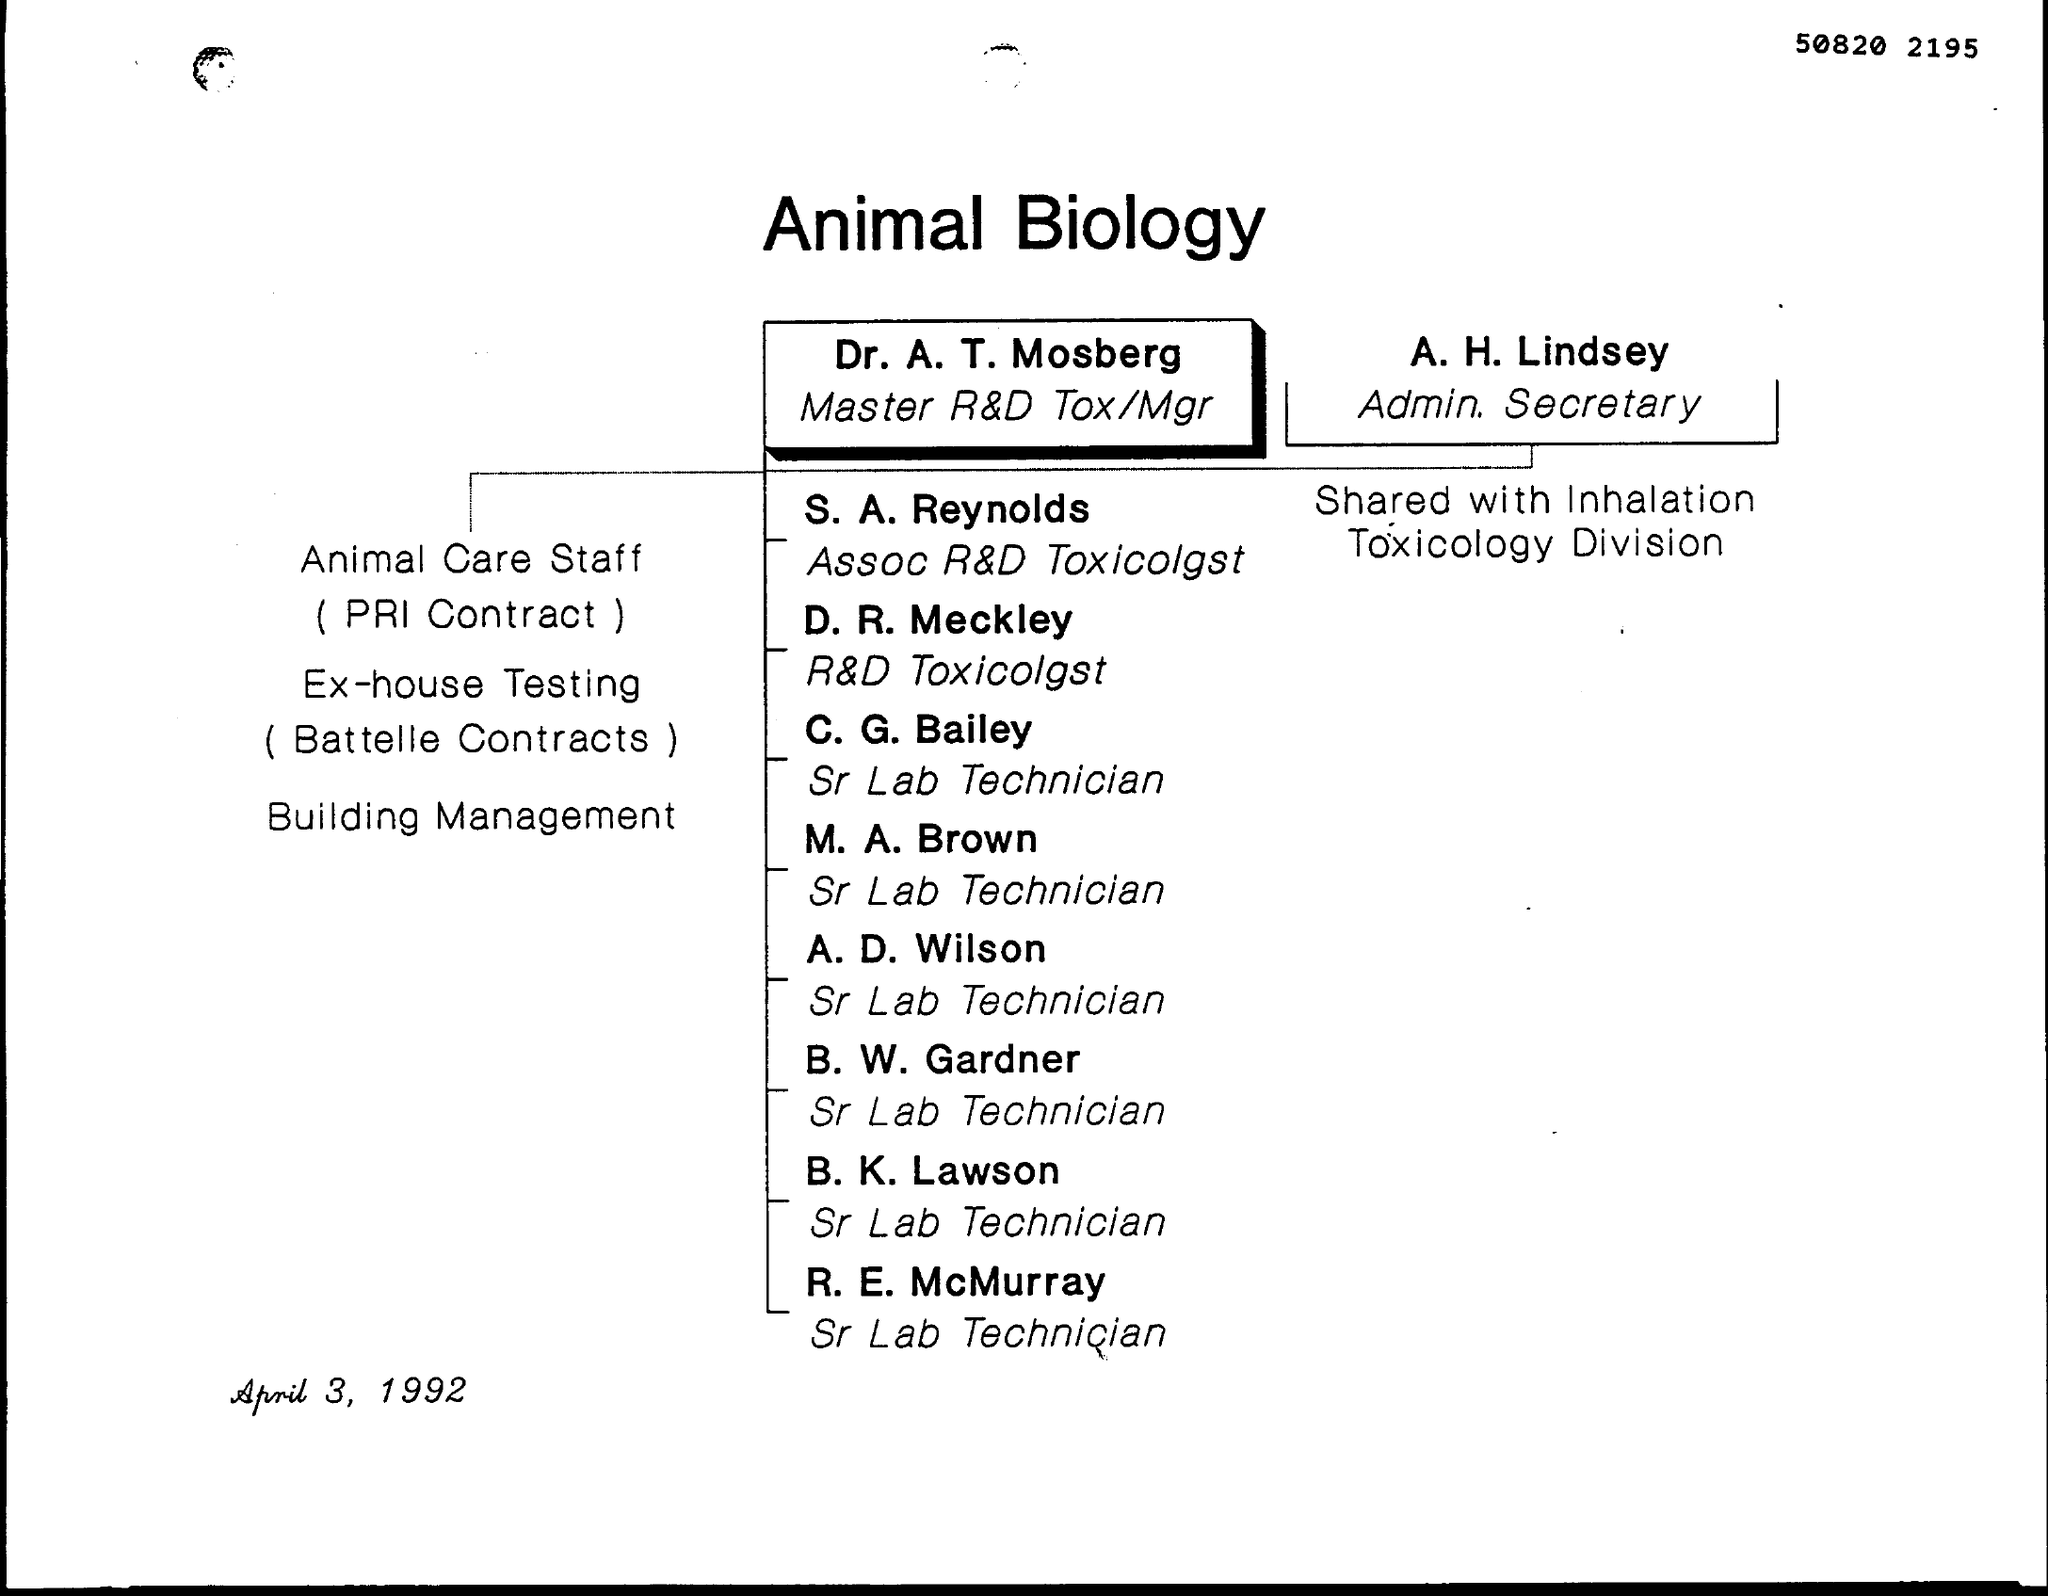Highlight a few significant elements in this photo. R. E. McMurray's designation is Senior Lab Technician. The title of the document is "Animal Biology. Animal care staff are hired through a contract with PRI Contract. 